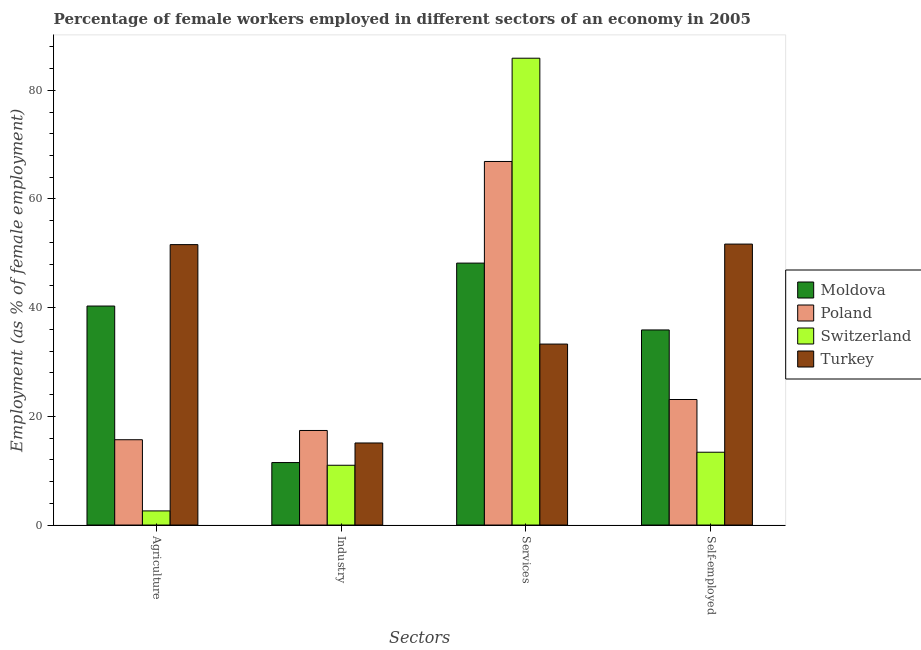How many bars are there on the 2nd tick from the right?
Your response must be concise. 4. What is the label of the 1st group of bars from the left?
Make the answer very short. Agriculture. What is the percentage of female workers in services in Turkey?
Offer a terse response. 33.3. Across all countries, what is the maximum percentage of female workers in services?
Your answer should be compact. 85.9. Across all countries, what is the minimum percentage of self employed female workers?
Provide a short and direct response. 13.4. In which country was the percentage of female workers in agriculture maximum?
Your answer should be compact. Turkey. In which country was the percentage of female workers in services minimum?
Your response must be concise. Turkey. What is the total percentage of female workers in services in the graph?
Your response must be concise. 234.3. What is the difference between the percentage of female workers in industry in Moldova and that in Poland?
Give a very brief answer. -5.9. What is the difference between the percentage of female workers in agriculture in Switzerland and the percentage of self employed female workers in Poland?
Give a very brief answer. -20.5. What is the average percentage of self employed female workers per country?
Give a very brief answer. 31.03. What is the difference between the percentage of female workers in agriculture and percentage of female workers in services in Poland?
Offer a very short reply. -51.2. In how many countries, is the percentage of female workers in services greater than 72 %?
Your response must be concise. 1. What is the ratio of the percentage of female workers in agriculture in Turkey to that in Poland?
Offer a terse response. 3.29. What is the difference between the highest and the second highest percentage of female workers in industry?
Give a very brief answer. 2.3. What is the difference between the highest and the lowest percentage of female workers in industry?
Your answer should be very brief. 6.4. What does the 2nd bar from the left in Self-employed represents?
Give a very brief answer. Poland. What does the 2nd bar from the right in Self-employed represents?
Keep it short and to the point. Switzerland. Is it the case that in every country, the sum of the percentage of female workers in agriculture and percentage of female workers in industry is greater than the percentage of female workers in services?
Give a very brief answer. No. How many bars are there?
Keep it short and to the point. 16. How many countries are there in the graph?
Keep it short and to the point. 4. How many legend labels are there?
Make the answer very short. 4. How are the legend labels stacked?
Offer a very short reply. Vertical. What is the title of the graph?
Keep it short and to the point. Percentage of female workers employed in different sectors of an economy in 2005. Does "High income" appear as one of the legend labels in the graph?
Your answer should be very brief. No. What is the label or title of the X-axis?
Your response must be concise. Sectors. What is the label or title of the Y-axis?
Your answer should be very brief. Employment (as % of female employment). What is the Employment (as % of female employment) of Moldova in Agriculture?
Give a very brief answer. 40.3. What is the Employment (as % of female employment) in Poland in Agriculture?
Provide a short and direct response. 15.7. What is the Employment (as % of female employment) of Switzerland in Agriculture?
Offer a very short reply. 2.6. What is the Employment (as % of female employment) in Turkey in Agriculture?
Make the answer very short. 51.6. What is the Employment (as % of female employment) in Poland in Industry?
Provide a succinct answer. 17.4. What is the Employment (as % of female employment) of Switzerland in Industry?
Your answer should be very brief. 11. What is the Employment (as % of female employment) in Turkey in Industry?
Your answer should be compact. 15.1. What is the Employment (as % of female employment) in Moldova in Services?
Ensure brevity in your answer.  48.2. What is the Employment (as % of female employment) in Poland in Services?
Your answer should be very brief. 66.9. What is the Employment (as % of female employment) of Switzerland in Services?
Give a very brief answer. 85.9. What is the Employment (as % of female employment) of Turkey in Services?
Keep it short and to the point. 33.3. What is the Employment (as % of female employment) in Moldova in Self-employed?
Make the answer very short. 35.9. What is the Employment (as % of female employment) in Poland in Self-employed?
Your response must be concise. 23.1. What is the Employment (as % of female employment) in Switzerland in Self-employed?
Provide a short and direct response. 13.4. What is the Employment (as % of female employment) in Turkey in Self-employed?
Provide a short and direct response. 51.7. Across all Sectors, what is the maximum Employment (as % of female employment) in Moldova?
Ensure brevity in your answer.  48.2. Across all Sectors, what is the maximum Employment (as % of female employment) in Poland?
Offer a terse response. 66.9. Across all Sectors, what is the maximum Employment (as % of female employment) of Switzerland?
Offer a terse response. 85.9. Across all Sectors, what is the maximum Employment (as % of female employment) of Turkey?
Your response must be concise. 51.7. Across all Sectors, what is the minimum Employment (as % of female employment) of Poland?
Ensure brevity in your answer.  15.7. Across all Sectors, what is the minimum Employment (as % of female employment) of Switzerland?
Your response must be concise. 2.6. Across all Sectors, what is the minimum Employment (as % of female employment) of Turkey?
Offer a terse response. 15.1. What is the total Employment (as % of female employment) of Moldova in the graph?
Your answer should be compact. 135.9. What is the total Employment (as % of female employment) in Poland in the graph?
Make the answer very short. 123.1. What is the total Employment (as % of female employment) of Switzerland in the graph?
Ensure brevity in your answer.  112.9. What is the total Employment (as % of female employment) in Turkey in the graph?
Your response must be concise. 151.7. What is the difference between the Employment (as % of female employment) of Moldova in Agriculture and that in Industry?
Provide a succinct answer. 28.8. What is the difference between the Employment (as % of female employment) of Poland in Agriculture and that in Industry?
Give a very brief answer. -1.7. What is the difference between the Employment (as % of female employment) of Turkey in Agriculture and that in Industry?
Your response must be concise. 36.5. What is the difference between the Employment (as % of female employment) of Moldova in Agriculture and that in Services?
Your answer should be compact. -7.9. What is the difference between the Employment (as % of female employment) of Poland in Agriculture and that in Services?
Ensure brevity in your answer.  -51.2. What is the difference between the Employment (as % of female employment) of Switzerland in Agriculture and that in Services?
Offer a very short reply. -83.3. What is the difference between the Employment (as % of female employment) of Turkey in Agriculture and that in Services?
Keep it short and to the point. 18.3. What is the difference between the Employment (as % of female employment) of Switzerland in Agriculture and that in Self-employed?
Your answer should be compact. -10.8. What is the difference between the Employment (as % of female employment) of Moldova in Industry and that in Services?
Provide a succinct answer. -36.7. What is the difference between the Employment (as % of female employment) of Poland in Industry and that in Services?
Your answer should be very brief. -49.5. What is the difference between the Employment (as % of female employment) of Switzerland in Industry and that in Services?
Give a very brief answer. -74.9. What is the difference between the Employment (as % of female employment) in Turkey in Industry and that in Services?
Provide a succinct answer. -18.2. What is the difference between the Employment (as % of female employment) of Moldova in Industry and that in Self-employed?
Your response must be concise. -24.4. What is the difference between the Employment (as % of female employment) of Poland in Industry and that in Self-employed?
Offer a very short reply. -5.7. What is the difference between the Employment (as % of female employment) of Turkey in Industry and that in Self-employed?
Make the answer very short. -36.6. What is the difference between the Employment (as % of female employment) of Poland in Services and that in Self-employed?
Offer a very short reply. 43.8. What is the difference between the Employment (as % of female employment) in Switzerland in Services and that in Self-employed?
Offer a very short reply. 72.5. What is the difference between the Employment (as % of female employment) of Turkey in Services and that in Self-employed?
Make the answer very short. -18.4. What is the difference between the Employment (as % of female employment) in Moldova in Agriculture and the Employment (as % of female employment) in Poland in Industry?
Offer a very short reply. 22.9. What is the difference between the Employment (as % of female employment) of Moldova in Agriculture and the Employment (as % of female employment) of Switzerland in Industry?
Provide a succinct answer. 29.3. What is the difference between the Employment (as % of female employment) in Moldova in Agriculture and the Employment (as % of female employment) in Turkey in Industry?
Your answer should be compact. 25.2. What is the difference between the Employment (as % of female employment) of Poland in Agriculture and the Employment (as % of female employment) of Switzerland in Industry?
Your answer should be very brief. 4.7. What is the difference between the Employment (as % of female employment) of Poland in Agriculture and the Employment (as % of female employment) of Turkey in Industry?
Offer a terse response. 0.6. What is the difference between the Employment (as % of female employment) of Moldova in Agriculture and the Employment (as % of female employment) of Poland in Services?
Offer a very short reply. -26.6. What is the difference between the Employment (as % of female employment) in Moldova in Agriculture and the Employment (as % of female employment) in Switzerland in Services?
Offer a very short reply. -45.6. What is the difference between the Employment (as % of female employment) of Moldova in Agriculture and the Employment (as % of female employment) of Turkey in Services?
Your response must be concise. 7. What is the difference between the Employment (as % of female employment) in Poland in Agriculture and the Employment (as % of female employment) in Switzerland in Services?
Offer a very short reply. -70.2. What is the difference between the Employment (as % of female employment) of Poland in Agriculture and the Employment (as % of female employment) of Turkey in Services?
Keep it short and to the point. -17.6. What is the difference between the Employment (as % of female employment) of Switzerland in Agriculture and the Employment (as % of female employment) of Turkey in Services?
Provide a succinct answer. -30.7. What is the difference between the Employment (as % of female employment) of Moldova in Agriculture and the Employment (as % of female employment) of Switzerland in Self-employed?
Your answer should be compact. 26.9. What is the difference between the Employment (as % of female employment) of Poland in Agriculture and the Employment (as % of female employment) of Switzerland in Self-employed?
Offer a very short reply. 2.3. What is the difference between the Employment (as % of female employment) of Poland in Agriculture and the Employment (as % of female employment) of Turkey in Self-employed?
Ensure brevity in your answer.  -36. What is the difference between the Employment (as % of female employment) of Switzerland in Agriculture and the Employment (as % of female employment) of Turkey in Self-employed?
Keep it short and to the point. -49.1. What is the difference between the Employment (as % of female employment) of Moldova in Industry and the Employment (as % of female employment) of Poland in Services?
Your answer should be compact. -55.4. What is the difference between the Employment (as % of female employment) of Moldova in Industry and the Employment (as % of female employment) of Switzerland in Services?
Offer a very short reply. -74.4. What is the difference between the Employment (as % of female employment) in Moldova in Industry and the Employment (as % of female employment) in Turkey in Services?
Provide a succinct answer. -21.8. What is the difference between the Employment (as % of female employment) of Poland in Industry and the Employment (as % of female employment) of Switzerland in Services?
Make the answer very short. -68.5. What is the difference between the Employment (as % of female employment) in Poland in Industry and the Employment (as % of female employment) in Turkey in Services?
Make the answer very short. -15.9. What is the difference between the Employment (as % of female employment) in Switzerland in Industry and the Employment (as % of female employment) in Turkey in Services?
Your answer should be very brief. -22.3. What is the difference between the Employment (as % of female employment) of Moldova in Industry and the Employment (as % of female employment) of Switzerland in Self-employed?
Your answer should be very brief. -1.9. What is the difference between the Employment (as % of female employment) of Moldova in Industry and the Employment (as % of female employment) of Turkey in Self-employed?
Provide a short and direct response. -40.2. What is the difference between the Employment (as % of female employment) in Poland in Industry and the Employment (as % of female employment) in Turkey in Self-employed?
Your answer should be compact. -34.3. What is the difference between the Employment (as % of female employment) of Switzerland in Industry and the Employment (as % of female employment) of Turkey in Self-employed?
Give a very brief answer. -40.7. What is the difference between the Employment (as % of female employment) in Moldova in Services and the Employment (as % of female employment) in Poland in Self-employed?
Give a very brief answer. 25.1. What is the difference between the Employment (as % of female employment) in Moldova in Services and the Employment (as % of female employment) in Switzerland in Self-employed?
Keep it short and to the point. 34.8. What is the difference between the Employment (as % of female employment) in Poland in Services and the Employment (as % of female employment) in Switzerland in Self-employed?
Give a very brief answer. 53.5. What is the difference between the Employment (as % of female employment) of Switzerland in Services and the Employment (as % of female employment) of Turkey in Self-employed?
Your response must be concise. 34.2. What is the average Employment (as % of female employment) of Moldova per Sectors?
Your answer should be very brief. 33.98. What is the average Employment (as % of female employment) of Poland per Sectors?
Ensure brevity in your answer.  30.77. What is the average Employment (as % of female employment) in Switzerland per Sectors?
Your answer should be compact. 28.23. What is the average Employment (as % of female employment) in Turkey per Sectors?
Provide a short and direct response. 37.92. What is the difference between the Employment (as % of female employment) of Moldova and Employment (as % of female employment) of Poland in Agriculture?
Give a very brief answer. 24.6. What is the difference between the Employment (as % of female employment) of Moldova and Employment (as % of female employment) of Switzerland in Agriculture?
Your answer should be very brief. 37.7. What is the difference between the Employment (as % of female employment) in Poland and Employment (as % of female employment) in Turkey in Agriculture?
Provide a succinct answer. -35.9. What is the difference between the Employment (as % of female employment) in Switzerland and Employment (as % of female employment) in Turkey in Agriculture?
Keep it short and to the point. -49. What is the difference between the Employment (as % of female employment) of Moldova and Employment (as % of female employment) of Switzerland in Industry?
Provide a succinct answer. 0.5. What is the difference between the Employment (as % of female employment) in Poland and Employment (as % of female employment) in Switzerland in Industry?
Provide a succinct answer. 6.4. What is the difference between the Employment (as % of female employment) in Poland and Employment (as % of female employment) in Turkey in Industry?
Your response must be concise. 2.3. What is the difference between the Employment (as % of female employment) in Moldova and Employment (as % of female employment) in Poland in Services?
Your answer should be compact. -18.7. What is the difference between the Employment (as % of female employment) of Moldova and Employment (as % of female employment) of Switzerland in Services?
Your response must be concise. -37.7. What is the difference between the Employment (as % of female employment) of Poland and Employment (as % of female employment) of Switzerland in Services?
Ensure brevity in your answer.  -19. What is the difference between the Employment (as % of female employment) in Poland and Employment (as % of female employment) in Turkey in Services?
Make the answer very short. 33.6. What is the difference between the Employment (as % of female employment) of Switzerland and Employment (as % of female employment) of Turkey in Services?
Provide a succinct answer. 52.6. What is the difference between the Employment (as % of female employment) in Moldova and Employment (as % of female employment) in Switzerland in Self-employed?
Offer a terse response. 22.5. What is the difference between the Employment (as % of female employment) of Moldova and Employment (as % of female employment) of Turkey in Self-employed?
Give a very brief answer. -15.8. What is the difference between the Employment (as % of female employment) of Poland and Employment (as % of female employment) of Switzerland in Self-employed?
Keep it short and to the point. 9.7. What is the difference between the Employment (as % of female employment) of Poland and Employment (as % of female employment) of Turkey in Self-employed?
Your answer should be very brief. -28.6. What is the difference between the Employment (as % of female employment) of Switzerland and Employment (as % of female employment) of Turkey in Self-employed?
Provide a succinct answer. -38.3. What is the ratio of the Employment (as % of female employment) of Moldova in Agriculture to that in Industry?
Your answer should be compact. 3.5. What is the ratio of the Employment (as % of female employment) in Poland in Agriculture to that in Industry?
Offer a terse response. 0.9. What is the ratio of the Employment (as % of female employment) in Switzerland in Agriculture to that in Industry?
Provide a short and direct response. 0.24. What is the ratio of the Employment (as % of female employment) in Turkey in Agriculture to that in Industry?
Offer a very short reply. 3.42. What is the ratio of the Employment (as % of female employment) of Moldova in Agriculture to that in Services?
Make the answer very short. 0.84. What is the ratio of the Employment (as % of female employment) of Poland in Agriculture to that in Services?
Make the answer very short. 0.23. What is the ratio of the Employment (as % of female employment) of Switzerland in Agriculture to that in Services?
Provide a succinct answer. 0.03. What is the ratio of the Employment (as % of female employment) in Turkey in Agriculture to that in Services?
Offer a very short reply. 1.55. What is the ratio of the Employment (as % of female employment) in Moldova in Agriculture to that in Self-employed?
Offer a very short reply. 1.12. What is the ratio of the Employment (as % of female employment) of Poland in Agriculture to that in Self-employed?
Your response must be concise. 0.68. What is the ratio of the Employment (as % of female employment) in Switzerland in Agriculture to that in Self-employed?
Provide a short and direct response. 0.19. What is the ratio of the Employment (as % of female employment) of Moldova in Industry to that in Services?
Your response must be concise. 0.24. What is the ratio of the Employment (as % of female employment) in Poland in Industry to that in Services?
Offer a very short reply. 0.26. What is the ratio of the Employment (as % of female employment) in Switzerland in Industry to that in Services?
Your answer should be compact. 0.13. What is the ratio of the Employment (as % of female employment) of Turkey in Industry to that in Services?
Provide a succinct answer. 0.45. What is the ratio of the Employment (as % of female employment) in Moldova in Industry to that in Self-employed?
Your response must be concise. 0.32. What is the ratio of the Employment (as % of female employment) in Poland in Industry to that in Self-employed?
Ensure brevity in your answer.  0.75. What is the ratio of the Employment (as % of female employment) of Switzerland in Industry to that in Self-employed?
Provide a short and direct response. 0.82. What is the ratio of the Employment (as % of female employment) in Turkey in Industry to that in Self-employed?
Your answer should be very brief. 0.29. What is the ratio of the Employment (as % of female employment) in Moldova in Services to that in Self-employed?
Your response must be concise. 1.34. What is the ratio of the Employment (as % of female employment) of Poland in Services to that in Self-employed?
Make the answer very short. 2.9. What is the ratio of the Employment (as % of female employment) in Switzerland in Services to that in Self-employed?
Offer a very short reply. 6.41. What is the ratio of the Employment (as % of female employment) in Turkey in Services to that in Self-employed?
Provide a short and direct response. 0.64. What is the difference between the highest and the second highest Employment (as % of female employment) of Moldova?
Your answer should be very brief. 7.9. What is the difference between the highest and the second highest Employment (as % of female employment) in Poland?
Offer a very short reply. 43.8. What is the difference between the highest and the second highest Employment (as % of female employment) in Switzerland?
Offer a terse response. 72.5. What is the difference between the highest and the lowest Employment (as % of female employment) in Moldova?
Ensure brevity in your answer.  36.7. What is the difference between the highest and the lowest Employment (as % of female employment) in Poland?
Offer a terse response. 51.2. What is the difference between the highest and the lowest Employment (as % of female employment) of Switzerland?
Ensure brevity in your answer.  83.3. What is the difference between the highest and the lowest Employment (as % of female employment) of Turkey?
Make the answer very short. 36.6. 